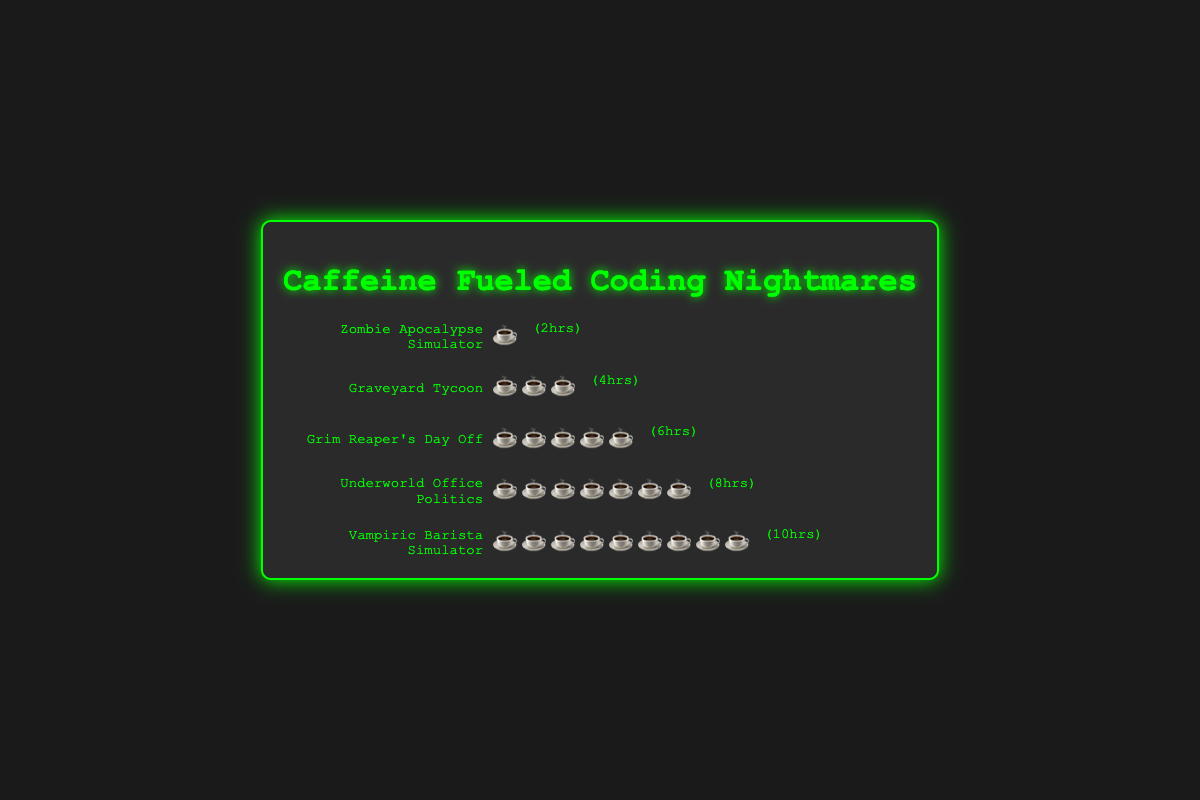What's the title of the figure? The title of the figure is prominently displayed at the top of the plot. Here, the title is "Caffeine Fueled Coding Nightmares".
Answer: "Caffeine Fueled Coding Nightmares" How many coffee cup icons are used to represent "Graveyard Tycoon"? Each coffee cup icon represents one cup of caffeine, as depicted with the coffee cup icons. "Graveyard Tycoon" is represented with three coffee cup icons.
Answer: 3 Which project required the highest amount of caffeine consumption? By counting the coffee cup icons, we can determine that "Vampiric Barista Simulator" has the most icons, with nine coffee cups.
Answer: "Vampiric Barista Simulator" Which project had the lowest ratio of caffeine cups to coding hours? To find the ratio for each project, divide the number of caffeine cups by the hours spent coding. The ratios are as follows: Zombie Apocalypse Simulator: 1/2, Graveyard Tycoon: 3/4, Grim Reaper's Day Off: 5/6, Underworld Office Politics: 7/8, Vampiric Barista Simulator: 9/10. The lowest ratio is for the "Zombie Apocalypse Simulator": 0.5.
Answer: "Zombie Apocalypse Simulator" How many total hours were spent coding across all projects? Sum the coding hours for all projects: 2 + 4 + 6 + 8 + 10 = 30 hours.
Answer: 30 hours How many cups of coffee were consumed in total? Sum the number of coffee cups for all projects: 1 + 3 + 5 + 7 + 9 = 25 cups.
Answer: 25 cups Which project had an equal number of coffee cups and hours spent coding? Look for projects where the number of coffee cups equals the hours spent coding. Here, none of the projects have equal numbers of coffee cups and hours spent coding.
Answer: None What's the average number of caffeine cups consumed per project? Calculate the average by dividing the total number of caffeine cups by the total number of projects: 25 cups / 5 projects = 5 cups per project.
Answer: 5 cups per project If a project had 12 hours of coding, how many coffee cups would you expect based on the observed trend? Based on the increasing trend where each hour of coding adds roughly 0.9 coffee cups (9 cups for 10 hours), for 12 hours we would expect roughly 12 * 0.9 = 10.8, rounding to approximately 11 coffee cups.
Answer: 11 coffee cups Which project had the highest ratio of caffeine cups to coding hours? Calculate the ratio of caffeine cups to hours for each project. The highest ratio is (9/10) for "Vampiric Barista Simulator" which simplifies to 0.9.
Answer: "Vampiric Barista Simulator" 